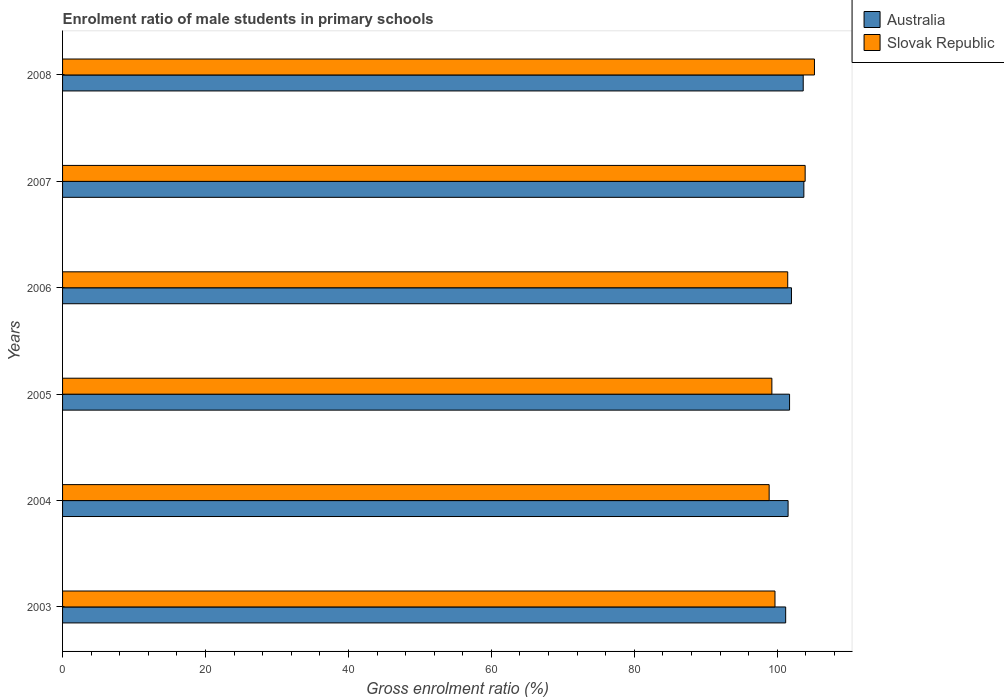How many different coloured bars are there?
Provide a succinct answer. 2. How many groups of bars are there?
Give a very brief answer. 6. How many bars are there on the 3rd tick from the bottom?
Provide a short and direct response. 2. In how many cases, is the number of bars for a given year not equal to the number of legend labels?
Provide a short and direct response. 0. What is the enrolment ratio of male students in primary schools in Australia in 2005?
Provide a short and direct response. 101.73. Across all years, what is the maximum enrolment ratio of male students in primary schools in Australia?
Provide a short and direct response. 103.73. Across all years, what is the minimum enrolment ratio of male students in primary schools in Australia?
Provide a short and direct response. 101.18. In which year was the enrolment ratio of male students in primary schools in Australia maximum?
Offer a very short reply. 2007. In which year was the enrolment ratio of male students in primary schools in Slovak Republic minimum?
Offer a very short reply. 2004. What is the total enrolment ratio of male students in primary schools in Australia in the graph?
Provide a succinct answer. 613.78. What is the difference between the enrolment ratio of male students in primary schools in Slovak Republic in 2006 and that in 2007?
Ensure brevity in your answer.  -2.44. What is the difference between the enrolment ratio of male students in primary schools in Slovak Republic in 2006 and the enrolment ratio of male students in primary schools in Australia in 2005?
Offer a very short reply. -0.26. What is the average enrolment ratio of male students in primary schools in Australia per year?
Keep it short and to the point. 102.3. In the year 2004, what is the difference between the enrolment ratio of male students in primary schools in Australia and enrolment ratio of male students in primary schools in Slovak Republic?
Offer a very short reply. 2.65. What is the ratio of the enrolment ratio of male students in primary schools in Australia in 2004 to that in 2006?
Your answer should be compact. 1. Is the enrolment ratio of male students in primary schools in Australia in 2004 less than that in 2005?
Your response must be concise. Yes. Is the difference between the enrolment ratio of male students in primary schools in Australia in 2003 and 2006 greater than the difference between the enrolment ratio of male students in primary schools in Slovak Republic in 2003 and 2006?
Your answer should be very brief. Yes. What is the difference between the highest and the second highest enrolment ratio of male students in primary schools in Slovak Republic?
Provide a short and direct response. 1.3. What is the difference between the highest and the lowest enrolment ratio of male students in primary schools in Slovak Republic?
Your answer should be very brief. 6.34. Is the sum of the enrolment ratio of male students in primary schools in Slovak Republic in 2005 and 2008 greater than the maximum enrolment ratio of male students in primary schools in Australia across all years?
Your response must be concise. Yes. What does the 2nd bar from the top in 2003 represents?
Your answer should be compact. Australia. Does the graph contain any zero values?
Your answer should be very brief. No. What is the title of the graph?
Make the answer very short. Enrolment ratio of male students in primary schools. What is the label or title of the Y-axis?
Your answer should be very brief. Years. What is the Gross enrolment ratio (%) of Australia in 2003?
Provide a succinct answer. 101.18. What is the Gross enrolment ratio (%) of Slovak Republic in 2003?
Make the answer very short. 99.69. What is the Gross enrolment ratio (%) of Australia in 2004?
Ensure brevity in your answer.  101.52. What is the Gross enrolment ratio (%) in Slovak Republic in 2004?
Your response must be concise. 98.87. What is the Gross enrolment ratio (%) in Australia in 2005?
Keep it short and to the point. 101.73. What is the Gross enrolment ratio (%) of Slovak Republic in 2005?
Ensure brevity in your answer.  99.25. What is the Gross enrolment ratio (%) in Australia in 2006?
Ensure brevity in your answer.  101.99. What is the Gross enrolment ratio (%) of Slovak Republic in 2006?
Ensure brevity in your answer.  101.47. What is the Gross enrolment ratio (%) of Australia in 2007?
Give a very brief answer. 103.73. What is the Gross enrolment ratio (%) in Slovak Republic in 2007?
Ensure brevity in your answer.  103.91. What is the Gross enrolment ratio (%) of Australia in 2008?
Make the answer very short. 103.64. What is the Gross enrolment ratio (%) of Slovak Republic in 2008?
Your response must be concise. 105.21. Across all years, what is the maximum Gross enrolment ratio (%) in Australia?
Your response must be concise. 103.73. Across all years, what is the maximum Gross enrolment ratio (%) of Slovak Republic?
Offer a terse response. 105.21. Across all years, what is the minimum Gross enrolment ratio (%) of Australia?
Keep it short and to the point. 101.18. Across all years, what is the minimum Gross enrolment ratio (%) in Slovak Republic?
Provide a short and direct response. 98.87. What is the total Gross enrolment ratio (%) in Australia in the graph?
Your answer should be very brief. 613.78. What is the total Gross enrolment ratio (%) of Slovak Republic in the graph?
Your answer should be compact. 608.4. What is the difference between the Gross enrolment ratio (%) of Australia in 2003 and that in 2004?
Your answer should be very brief. -0.34. What is the difference between the Gross enrolment ratio (%) in Slovak Republic in 2003 and that in 2004?
Your answer should be very brief. 0.82. What is the difference between the Gross enrolment ratio (%) of Australia in 2003 and that in 2005?
Your response must be concise. -0.55. What is the difference between the Gross enrolment ratio (%) of Slovak Republic in 2003 and that in 2005?
Offer a very short reply. 0.44. What is the difference between the Gross enrolment ratio (%) in Australia in 2003 and that in 2006?
Offer a very short reply. -0.81. What is the difference between the Gross enrolment ratio (%) in Slovak Republic in 2003 and that in 2006?
Your answer should be very brief. -1.78. What is the difference between the Gross enrolment ratio (%) of Australia in 2003 and that in 2007?
Provide a short and direct response. -2.54. What is the difference between the Gross enrolment ratio (%) in Slovak Republic in 2003 and that in 2007?
Provide a short and direct response. -4.22. What is the difference between the Gross enrolment ratio (%) in Australia in 2003 and that in 2008?
Give a very brief answer. -2.46. What is the difference between the Gross enrolment ratio (%) in Slovak Republic in 2003 and that in 2008?
Keep it short and to the point. -5.52. What is the difference between the Gross enrolment ratio (%) in Australia in 2004 and that in 2005?
Make the answer very short. -0.21. What is the difference between the Gross enrolment ratio (%) of Slovak Republic in 2004 and that in 2005?
Make the answer very short. -0.38. What is the difference between the Gross enrolment ratio (%) of Australia in 2004 and that in 2006?
Give a very brief answer. -0.47. What is the difference between the Gross enrolment ratio (%) in Slovak Republic in 2004 and that in 2006?
Offer a terse response. -2.6. What is the difference between the Gross enrolment ratio (%) of Australia in 2004 and that in 2007?
Your answer should be compact. -2.2. What is the difference between the Gross enrolment ratio (%) of Slovak Republic in 2004 and that in 2007?
Your answer should be compact. -5.04. What is the difference between the Gross enrolment ratio (%) of Australia in 2004 and that in 2008?
Provide a short and direct response. -2.12. What is the difference between the Gross enrolment ratio (%) in Slovak Republic in 2004 and that in 2008?
Provide a short and direct response. -6.34. What is the difference between the Gross enrolment ratio (%) in Australia in 2005 and that in 2006?
Provide a succinct answer. -0.27. What is the difference between the Gross enrolment ratio (%) of Slovak Republic in 2005 and that in 2006?
Offer a very short reply. -2.22. What is the difference between the Gross enrolment ratio (%) in Australia in 2005 and that in 2007?
Make the answer very short. -2. What is the difference between the Gross enrolment ratio (%) in Slovak Republic in 2005 and that in 2007?
Provide a short and direct response. -4.66. What is the difference between the Gross enrolment ratio (%) in Australia in 2005 and that in 2008?
Provide a short and direct response. -1.91. What is the difference between the Gross enrolment ratio (%) in Slovak Republic in 2005 and that in 2008?
Your response must be concise. -5.96. What is the difference between the Gross enrolment ratio (%) in Australia in 2006 and that in 2007?
Keep it short and to the point. -1.73. What is the difference between the Gross enrolment ratio (%) of Slovak Republic in 2006 and that in 2007?
Keep it short and to the point. -2.44. What is the difference between the Gross enrolment ratio (%) of Australia in 2006 and that in 2008?
Make the answer very short. -1.64. What is the difference between the Gross enrolment ratio (%) in Slovak Republic in 2006 and that in 2008?
Ensure brevity in your answer.  -3.74. What is the difference between the Gross enrolment ratio (%) of Australia in 2007 and that in 2008?
Your answer should be very brief. 0.09. What is the difference between the Gross enrolment ratio (%) of Slovak Republic in 2007 and that in 2008?
Ensure brevity in your answer.  -1.3. What is the difference between the Gross enrolment ratio (%) of Australia in 2003 and the Gross enrolment ratio (%) of Slovak Republic in 2004?
Ensure brevity in your answer.  2.31. What is the difference between the Gross enrolment ratio (%) of Australia in 2003 and the Gross enrolment ratio (%) of Slovak Republic in 2005?
Give a very brief answer. 1.93. What is the difference between the Gross enrolment ratio (%) of Australia in 2003 and the Gross enrolment ratio (%) of Slovak Republic in 2006?
Your answer should be very brief. -0.29. What is the difference between the Gross enrolment ratio (%) in Australia in 2003 and the Gross enrolment ratio (%) in Slovak Republic in 2007?
Make the answer very short. -2.73. What is the difference between the Gross enrolment ratio (%) in Australia in 2003 and the Gross enrolment ratio (%) in Slovak Republic in 2008?
Offer a terse response. -4.03. What is the difference between the Gross enrolment ratio (%) of Australia in 2004 and the Gross enrolment ratio (%) of Slovak Republic in 2005?
Your answer should be compact. 2.27. What is the difference between the Gross enrolment ratio (%) of Australia in 2004 and the Gross enrolment ratio (%) of Slovak Republic in 2006?
Your answer should be compact. 0.05. What is the difference between the Gross enrolment ratio (%) in Australia in 2004 and the Gross enrolment ratio (%) in Slovak Republic in 2007?
Keep it short and to the point. -2.39. What is the difference between the Gross enrolment ratio (%) of Australia in 2004 and the Gross enrolment ratio (%) of Slovak Republic in 2008?
Keep it short and to the point. -3.69. What is the difference between the Gross enrolment ratio (%) in Australia in 2005 and the Gross enrolment ratio (%) in Slovak Republic in 2006?
Ensure brevity in your answer.  0.26. What is the difference between the Gross enrolment ratio (%) of Australia in 2005 and the Gross enrolment ratio (%) of Slovak Republic in 2007?
Keep it short and to the point. -2.18. What is the difference between the Gross enrolment ratio (%) of Australia in 2005 and the Gross enrolment ratio (%) of Slovak Republic in 2008?
Your answer should be compact. -3.48. What is the difference between the Gross enrolment ratio (%) of Australia in 2006 and the Gross enrolment ratio (%) of Slovak Republic in 2007?
Your answer should be very brief. -1.91. What is the difference between the Gross enrolment ratio (%) in Australia in 2006 and the Gross enrolment ratio (%) in Slovak Republic in 2008?
Give a very brief answer. -3.22. What is the difference between the Gross enrolment ratio (%) of Australia in 2007 and the Gross enrolment ratio (%) of Slovak Republic in 2008?
Offer a very short reply. -1.48. What is the average Gross enrolment ratio (%) in Australia per year?
Keep it short and to the point. 102.3. What is the average Gross enrolment ratio (%) of Slovak Republic per year?
Your answer should be very brief. 101.4. In the year 2003, what is the difference between the Gross enrolment ratio (%) in Australia and Gross enrolment ratio (%) in Slovak Republic?
Provide a succinct answer. 1.49. In the year 2004, what is the difference between the Gross enrolment ratio (%) in Australia and Gross enrolment ratio (%) in Slovak Republic?
Your answer should be compact. 2.65. In the year 2005, what is the difference between the Gross enrolment ratio (%) in Australia and Gross enrolment ratio (%) in Slovak Republic?
Ensure brevity in your answer.  2.47. In the year 2006, what is the difference between the Gross enrolment ratio (%) in Australia and Gross enrolment ratio (%) in Slovak Republic?
Offer a very short reply. 0.52. In the year 2007, what is the difference between the Gross enrolment ratio (%) in Australia and Gross enrolment ratio (%) in Slovak Republic?
Your answer should be compact. -0.18. In the year 2008, what is the difference between the Gross enrolment ratio (%) of Australia and Gross enrolment ratio (%) of Slovak Republic?
Give a very brief answer. -1.57. What is the ratio of the Gross enrolment ratio (%) of Australia in 2003 to that in 2004?
Make the answer very short. 1. What is the ratio of the Gross enrolment ratio (%) of Slovak Republic in 2003 to that in 2004?
Provide a succinct answer. 1.01. What is the ratio of the Gross enrolment ratio (%) in Australia in 2003 to that in 2006?
Make the answer very short. 0.99. What is the ratio of the Gross enrolment ratio (%) of Slovak Republic in 2003 to that in 2006?
Keep it short and to the point. 0.98. What is the ratio of the Gross enrolment ratio (%) in Australia in 2003 to that in 2007?
Provide a succinct answer. 0.98. What is the ratio of the Gross enrolment ratio (%) in Slovak Republic in 2003 to that in 2007?
Your answer should be very brief. 0.96. What is the ratio of the Gross enrolment ratio (%) of Australia in 2003 to that in 2008?
Give a very brief answer. 0.98. What is the ratio of the Gross enrolment ratio (%) of Slovak Republic in 2003 to that in 2008?
Ensure brevity in your answer.  0.95. What is the ratio of the Gross enrolment ratio (%) in Australia in 2004 to that in 2005?
Your response must be concise. 1. What is the ratio of the Gross enrolment ratio (%) of Australia in 2004 to that in 2006?
Give a very brief answer. 1. What is the ratio of the Gross enrolment ratio (%) of Slovak Republic in 2004 to that in 2006?
Your answer should be compact. 0.97. What is the ratio of the Gross enrolment ratio (%) of Australia in 2004 to that in 2007?
Your answer should be very brief. 0.98. What is the ratio of the Gross enrolment ratio (%) of Slovak Republic in 2004 to that in 2007?
Keep it short and to the point. 0.95. What is the ratio of the Gross enrolment ratio (%) of Australia in 2004 to that in 2008?
Offer a very short reply. 0.98. What is the ratio of the Gross enrolment ratio (%) of Slovak Republic in 2004 to that in 2008?
Your answer should be very brief. 0.94. What is the ratio of the Gross enrolment ratio (%) in Slovak Republic in 2005 to that in 2006?
Your response must be concise. 0.98. What is the ratio of the Gross enrolment ratio (%) in Australia in 2005 to that in 2007?
Provide a succinct answer. 0.98. What is the ratio of the Gross enrolment ratio (%) in Slovak Republic in 2005 to that in 2007?
Your answer should be very brief. 0.96. What is the ratio of the Gross enrolment ratio (%) of Australia in 2005 to that in 2008?
Offer a terse response. 0.98. What is the ratio of the Gross enrolment ratio (%) of Slovak Republic in 2005 to that in 2008?
Offer a terse response. 0.94. What is the ratio of the Gross enrolment ratio (%) of Australia in 2006 to that in 2007?
Offer a very short reply. 0.98. What is the ratio of the Gross enrolment ratio (%) in Slovak Republic in 2006 to that in 2007?
Offer a terse response. 0.98. What is the ratio of the Gross enrolment ratio (%) of Australia in 2006 to that in 2008?
Your answer should be compact. 0.98. What is the ratio of the Gross enrolment ratio (%) in Slovak Republic in 2006 to that in 2008?
Offer a very short reply. 0.96. What is the ratio of the Gross enrolment ratio (%) in Slovak Republic in 2007 to that in 2008?
Give a very brief answer. 0.99. What is the difference between the highest and the second highest Gross enrolment ratio (%) of Australia?
Offer a terse response. 0.09. What is the difference between the highest and the second highest Gross enrolment ratio (%) in Slovak Republic?
Make the answer very short. 1.3. What is the difference between the highest and the lowest Gross enrolment ratio (%) in Australia?
Your answer should be compact. 2.54. What is the difference between the highest and the lowest Gross enrolment ratio (%) of Slovak Republic?
Offer a terse response. 6.34. 